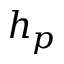<formula> <loc_0><loc_0><loc_500><loc_500>h _ { p }</formula> 